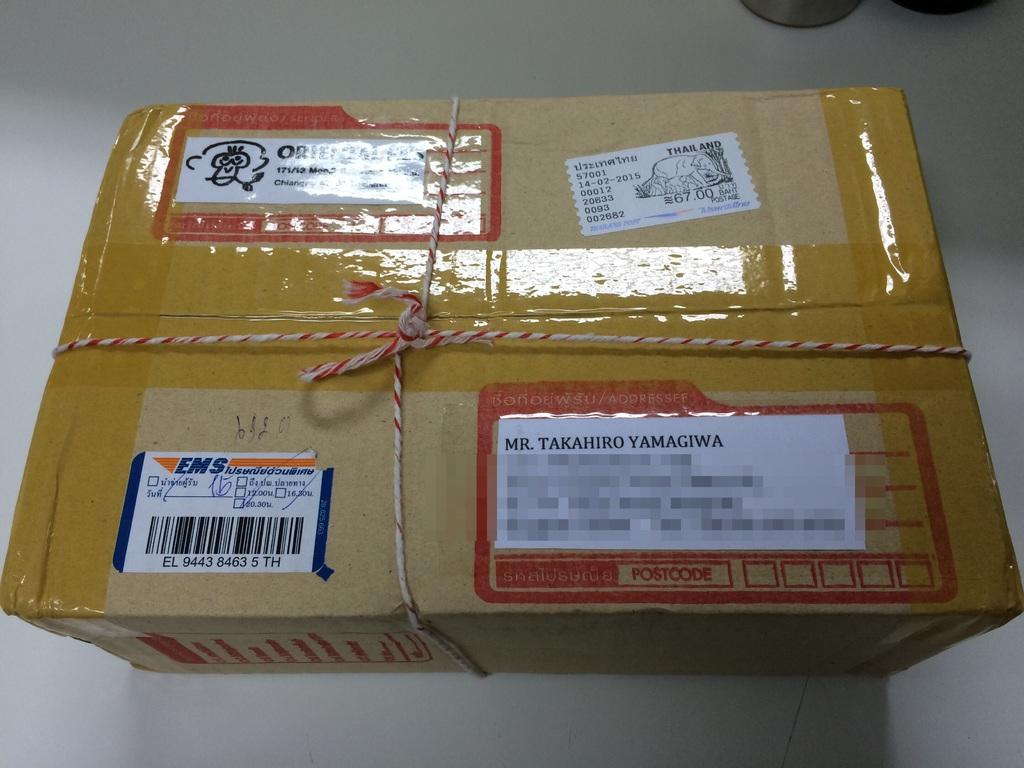<image>
Write a terse but informative summary of the picture. A box with a sticker that has the word Thailand on it is addressed to be mailed. 